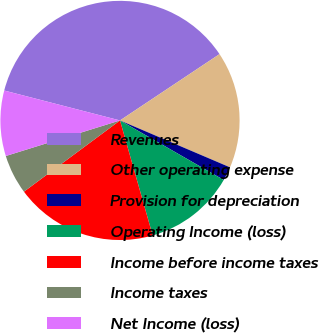<chart> <loc_0><loc_0><loc_500><loc_500><pie_chart><fcel>Revenues<fcel>Other operating expense<fcel>Provision for depreciation<fcel>Operating Income (loss)<fcel>Income before income taxes<fcel>Income taxes<fcel>Net Income (loss)<nl><fcel>36.62%<fcel>15.77%<fcel>1.88%<fcel>12.3%<fcel>19.25%<fcel>5.35%<fcel>8.83%<nl></chart> 